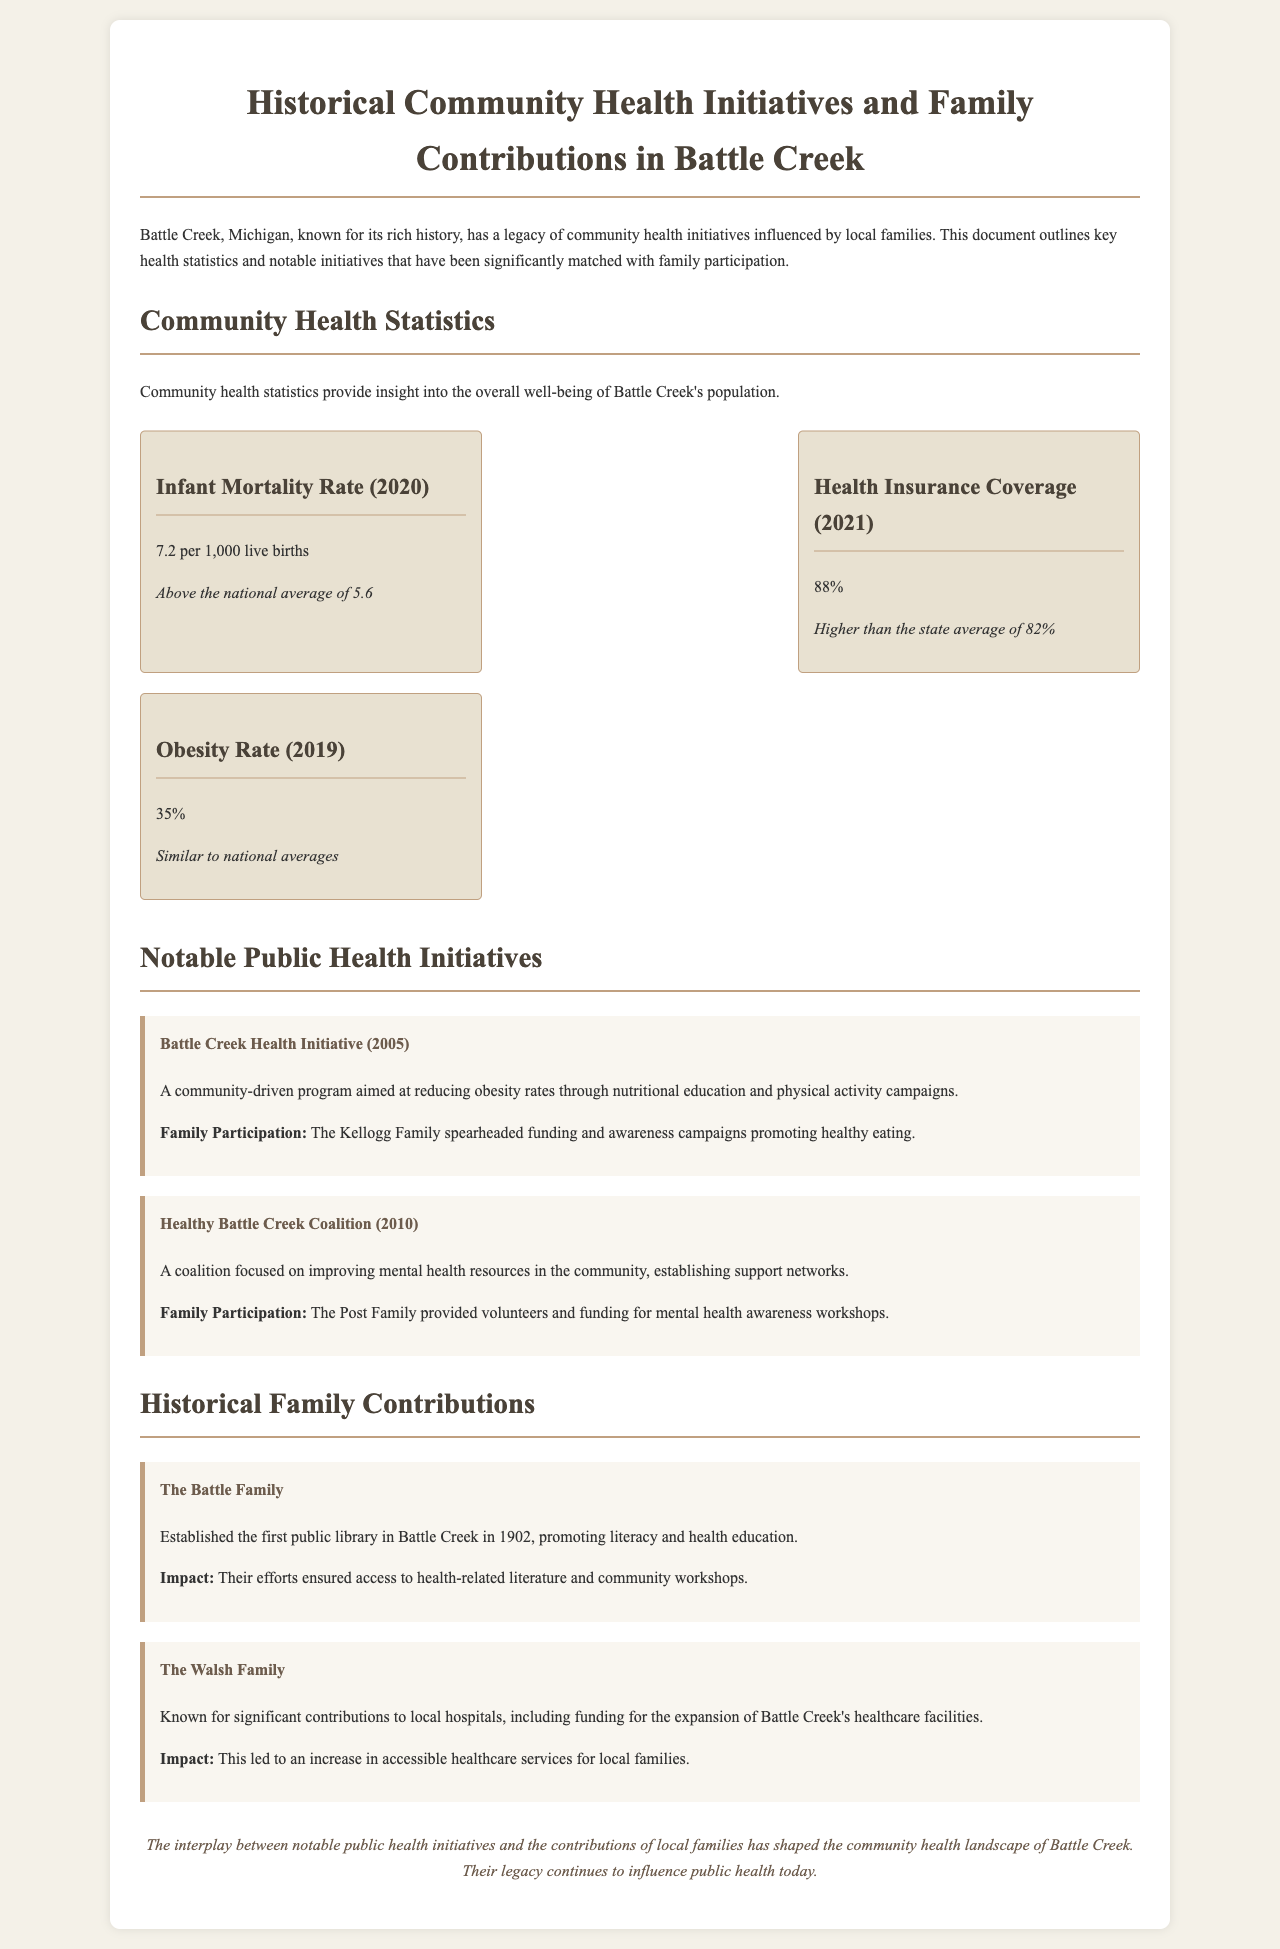what was the infant mortality rate in 2020? The document states the infant mortality rate as 7.2 per 1,000 live births for the year 2020.
Answer: 7.2 per 1,000 live births who spearheaded the Battle Creek Health Initiative in 2005? The Kellogg Family is noted for spearheading funding and awareness campaigns for the Battle Creek Health Initiative.
Answer: Kellogg Family what is the health insurance coverage percentage for Battle Creek in 2021? The document mentions that the health insurance coverage in Battle Creek was 88% in 2021.
Answer: 88% which family established the first public library in Battle Creek? The Battle Family is credited with establishing the first public library in Battle Creek in 1902.
Answer: Battle Family how much was the obesity rate reported in 2019? The obesity rate in 2019 was reported at 35%.
Answer: 35% what notable initiative was introduced in 2010? The Healthy Battle Creek Coalition was introduced in 2010 to improve mental health resources.
Answer: Healthy Battle Creek Coalition what impact did the Walsh Family have on local hospitals? The Walsh Family contributed significant funding for the expansion of Battle Creek's healthcare facilities.
Answer: funding for expansion which initiative aimed at reducing obesity through nutritional education? The Battle Creek Health Initiative aimed to reduce obesity through nutritional education and physical activity campaigns.
Answer: Battle Creek Health Initiative 